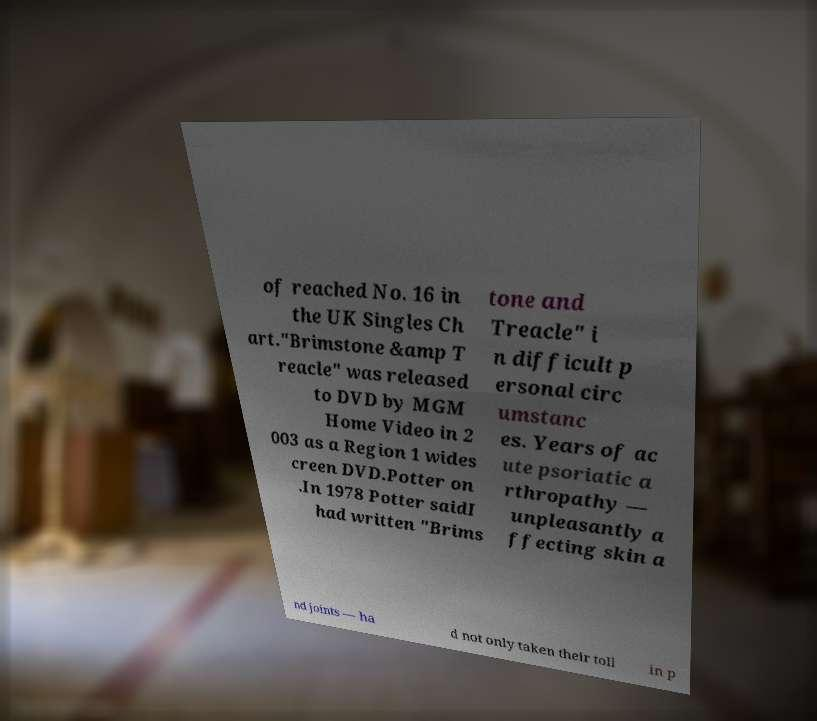Could you assist in decoding the text presented in this image and type it out clearly? of reached No. 16 in the UK Singles Ch art."Brimstone &amp T reacle" was released to DVD by MGM Home Video in 2 003 as a Region 1 wides creen DVD.Potter on .In 1978 Potter saidI had written "Brims tone and Treacle" i n difficult p ersonal circ umstanc es. Years of ac ute psoriatic a rthropathy — unpleasantly a ffecting skin a nd joints — ha d not only taken their toll in p 